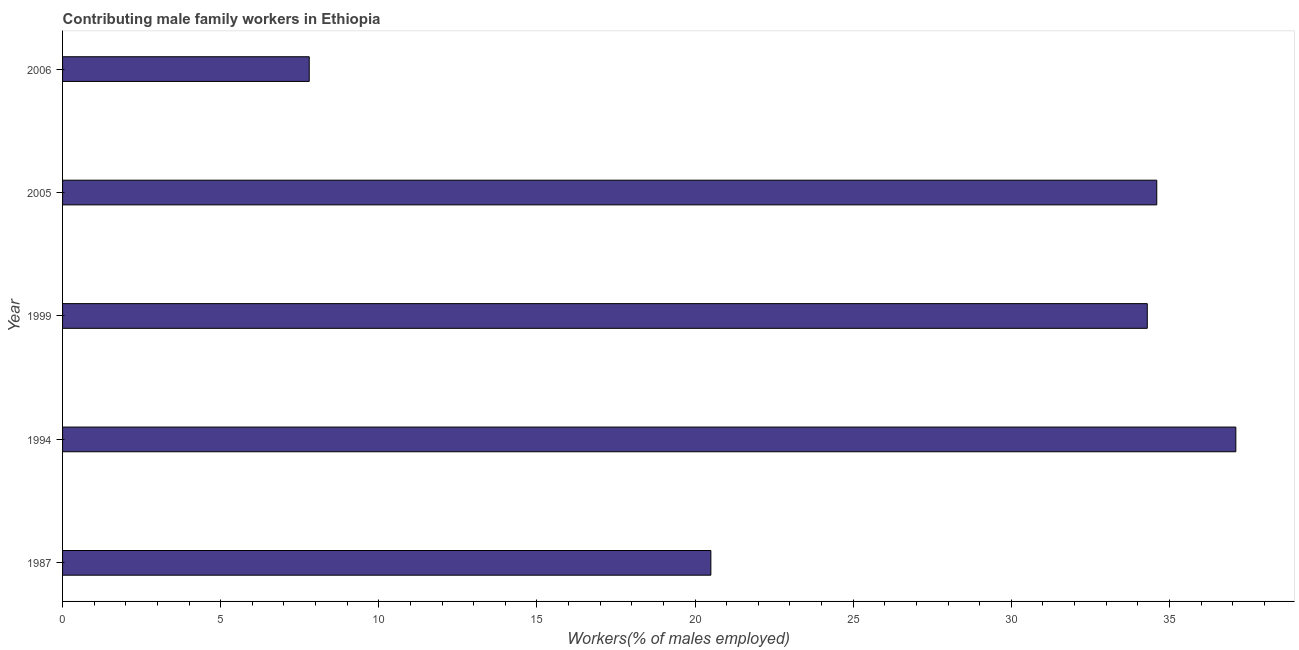Does the graph contain grids?
Provide a short and direct response. No. What is the title of the graph?
Provide a short and direct response. Contributing male family workers in Ethiopia. What is the label or title of the X-axis?
Your answer should be very brief. Workers(% of males employed). What is the label or title of the Y-axis?
Provide a succinct answer. Year. What is the contributing male family workers in 2006?
Offer a terse response. 7.8. Across all years, what is the maximum contributing male family workers?
Your answer should be compact. 37.1. Across all years, what is the minimum contributing male family workers?
Provide a short and direct response. 7.8. In which year was the contributing male family workers maximum?
Offer a very short reply. 1994. In which year was the contributing male family workers minimum?
Offer a terse response. 2006. What is the sum of the contributing male family workers?
Provide a short and direct response. 134.3. What is the difference between the contributing male family workers in 1987 and 1999?
Your answer should be very brief. -13.8. What is the average contributing male family workers per year?
Provide a succinct answer. 26.86. What is the median contributing male family workers?
Offer a terse response. 34.3. In how many years, is the contributing male family workers greater than 36 %?
Your answer should be compact. 1. What is the ratio of the contributing male family workers in 1994 to that in 2005?
Provide a short and direct response. 1.07. Is the contributing male family workers in 1987 less than that in 2005?
Your answer should be very brief. Yes. Is the difference between the contributing male family workers in 2005 and 2006 greater than the difference between any two years?
Offer a very short reply. No. What is the difference between the highest and the second highest contributing male family workers?
Offer a terse response. 2.5. Is the sum of the contributing male family workers in 1987 and 1999 greater than the maximum contributing male family workers across all years?
Provide a short and direct response. Yes. What is the difference between the highest and the lowest contributing male family workers?
Offer a very short reply. 29.3. How many bars are there?
Your response must be concise. 5. What is the Workers(% of males employed) of 1987?
Give a very brief answer. 20.5. What is the Workers(% of males employed) of 1994?
Your answer should be compact. 37.1. What is the Workers(% of males employed) of 1999?
Your answer should be compact. 34.3. What is the Workers(% of males employed) in 2005?
Keep it short and to the point. 34.6. What is the Workers(% of males employed) of 2006?
Provide a succinct answer. 7.8. What is the difference between the Workers(% of males employed) in 1987 and 1994?
Your answer should be compact. -16.6. What is the difference between the Workers(% of males employed) in 1987 and 2005?
Provide a succinct answer. -14.1. What is the difference between the Workers(% of males employed) in 1987 and 2006?
Ensure brevity in your answer.  12.7. What is the difference between the Workers(% of males employed) in 1994 and 2005?
Keep it short and to the point. 2.5. What is the difference between the Workers(% of males employed) in 1994 and 2006?
Your answer should be very brief. 29.3. What is the difference between the Workers(% of males employed) in 1999 and 2005?
Make the answer very short. -0.3. What is the difference between the Workers(% of males employed) in 2005 and 2006?
Offer a very short reply. 26.8. What is the ratio of the Workers(% of males employed) in 1987 to that in 1994?
Keep it short and to the point. 0.55. What is the ratio of the Workers(% of males employed) in 1987 to that in 1999?
Ensure brevity in your answer.  0.6. What is the ratio of the Workers(% of males employed) in 1987 to that in 2005?
Make the answer very short. 0.59. What is the ratio of the Workers(% of males employed) in 1987 to that in 2006?
Provide a short and direct response. 2.63. What is the ratio of the Workers(% of males employed) in 1994 to that in 1999?
Keep it short and to the point. 1.08. What is the ratio of the Workers(% of males employed) in 1994 to that in 2005?
Your response must be concise. 1.07. What is the ratio of the Workers(% of males employed) in 1994 to that in 2006?
Your answer should be very brief. 4.76. What is the ratio of the Workers(% of males employed) in 1999 to that in 2006?
Provide a succinct answer. 4.4. What is the ratio of the Workers(% of males employed) in 2005 to that in 2006?
Provide a short and direct response. 4.44. 